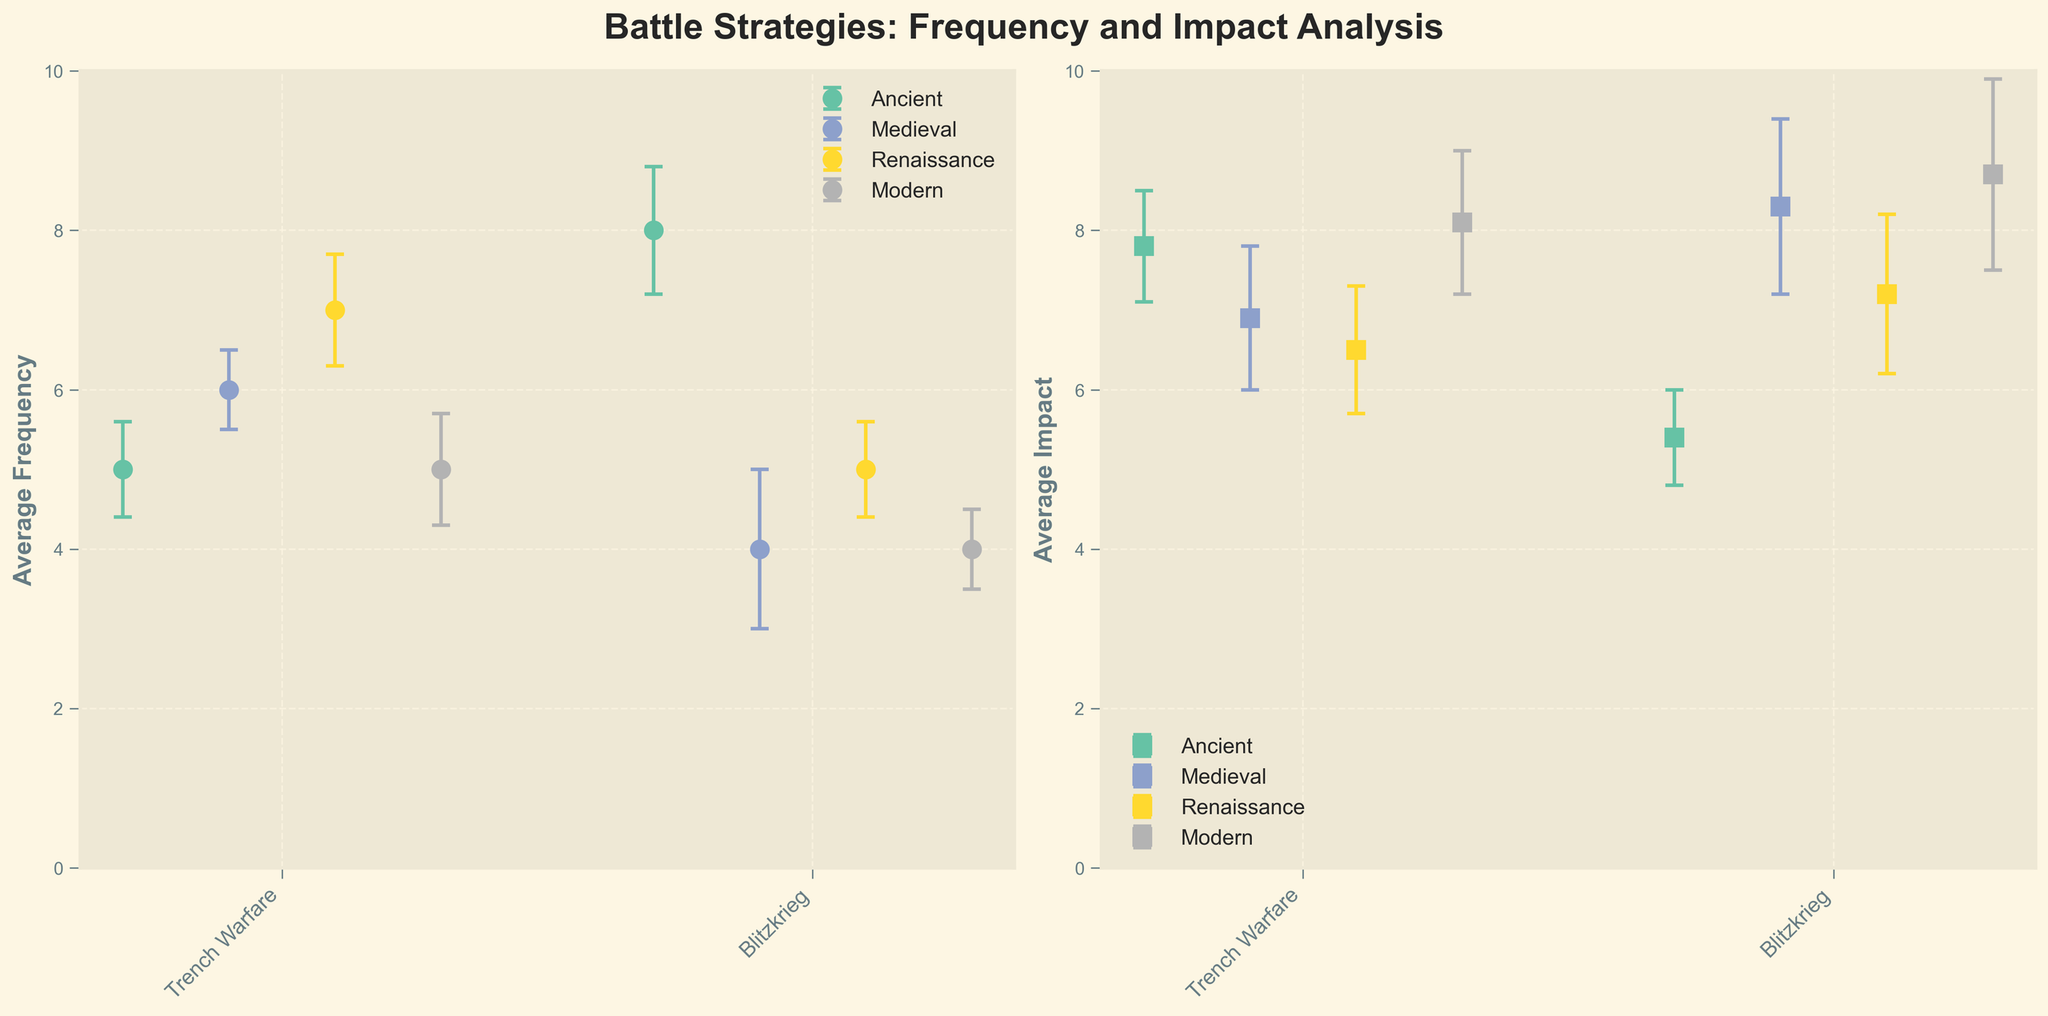what is the average frequency of the "Phalanx" strategy in the Ancient era? By looking at the "average frequency" value of the "Phalanx" strategy in the Ancient era subplot, we can see that it is listed as 5.
Answer: 5 Which era shows the largest error bar in "average impact" for any strategy? From the subplots, we observe that error bars represent standard deviations. In the Renaissance era, the "Artillery Barrage" strategy has the largest error bar for "average impact," which is visually identifiable as longer.
Answer: Renaissance What is the combined average impact of "Blitzkrieg" and "Trench Warfare" in the Modern era? Adding the "average impact" values of both "Blitzkrieg" and "Trench Warfare" strategies in the Modern era subplot, we have 8.7 + 8.1 = 16.8.
Answer: 16.8 How does the average frequency of "Infantry Charge" in the Ancient era compare to "Cavalry Charge" in the Medieval era? Compare the average frequency of "Infantry Charge" from the Ancient era (8) with "Cavalry Charge" from the Medieval era (6). 8 is greater than 6.
Answer: Greater Which battle strategy has the highest average impact overall, and in which era is it observed? By comparing the average impact across all strategies in each subplot, "Blitzkrieg" in the Modern era registers the highest average impact at 8.7.
Answer: Blitzkrieg in the Modern era Are there any strategies with significant standard deviations in their average frequency? If so, which one and by how much? By examining the error bars representing standard deviations in the subplots, the "Siege Warfare" in the Medieval era has a substantial standard deviation in average frequency, which is 1.0.
Answer: Siege Warfare with 1.0 Which era has the least variation in "average impact" across its listed strategies? To identify the era with the least variance, look at the length of error bars in the subplots for "average impact." The Renaissance era has relatively smaller error bars overall, indicating lower variance.
Answer: Renaissance What is the difference in average impact between "Cavalry Charge" in the Medieval era and "Line Formation" in the Renaissance era? Subtract the average impact of "Line Formation" in the Renaissance era (6.5) from "Cavalry Charge" in the Medieval era (6.9), giving 6.9 - 6.5 = 0.4.
Answer: 0.4 If we sum the average frequencies of "Phalanx" and "Siege Warfare," what would be the result? Adding the average frequency of the "Phalanx" strategy (5) and "Siege Warfare" (4), we get 5 + 4 = 9.
Answer: 9 